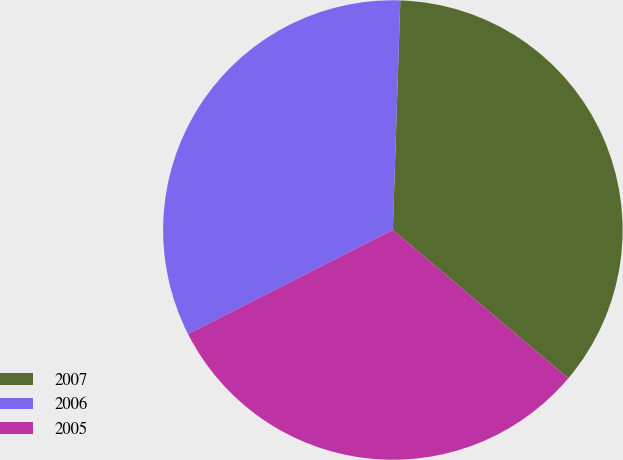Convert chart to OTSL. <chart><loc_0><loc_0><loc_500><loc_500><pie_chart><fcel>2007<fcel>2006<fcel>2005<nl><fcel>35.65%<fcel>33.0%<fcel>31.35%<nl></chart> 